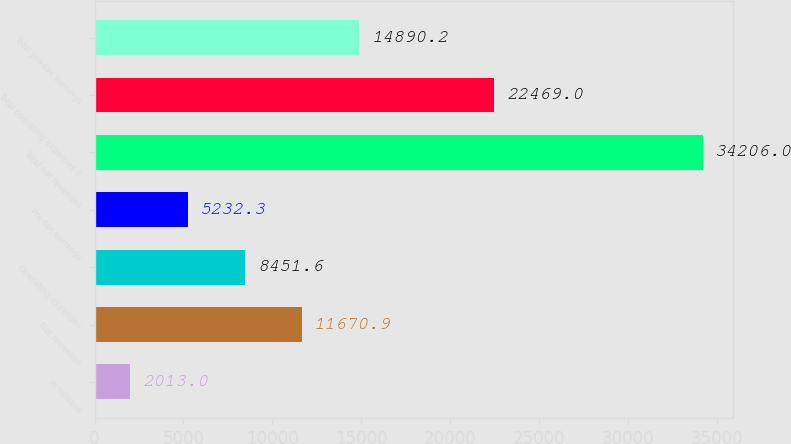Convert chart. <chart><loc_0><loc_0><loc_500><loc_500><bar_chart><fcel>in millions<fcel>Net revenues<fcel>Operating expenses<fcel>Pre-tax earnings<fcel>Total net revenues<fcel>Total operating expenses 1<fcel>Total pre-tax earnings<nl><fcel>2013<fcel>11670.9<fcel>8451.6<fcel>5232.3<fcel>34206<fcel>22469<fcel>14890.2<nl></chart> 